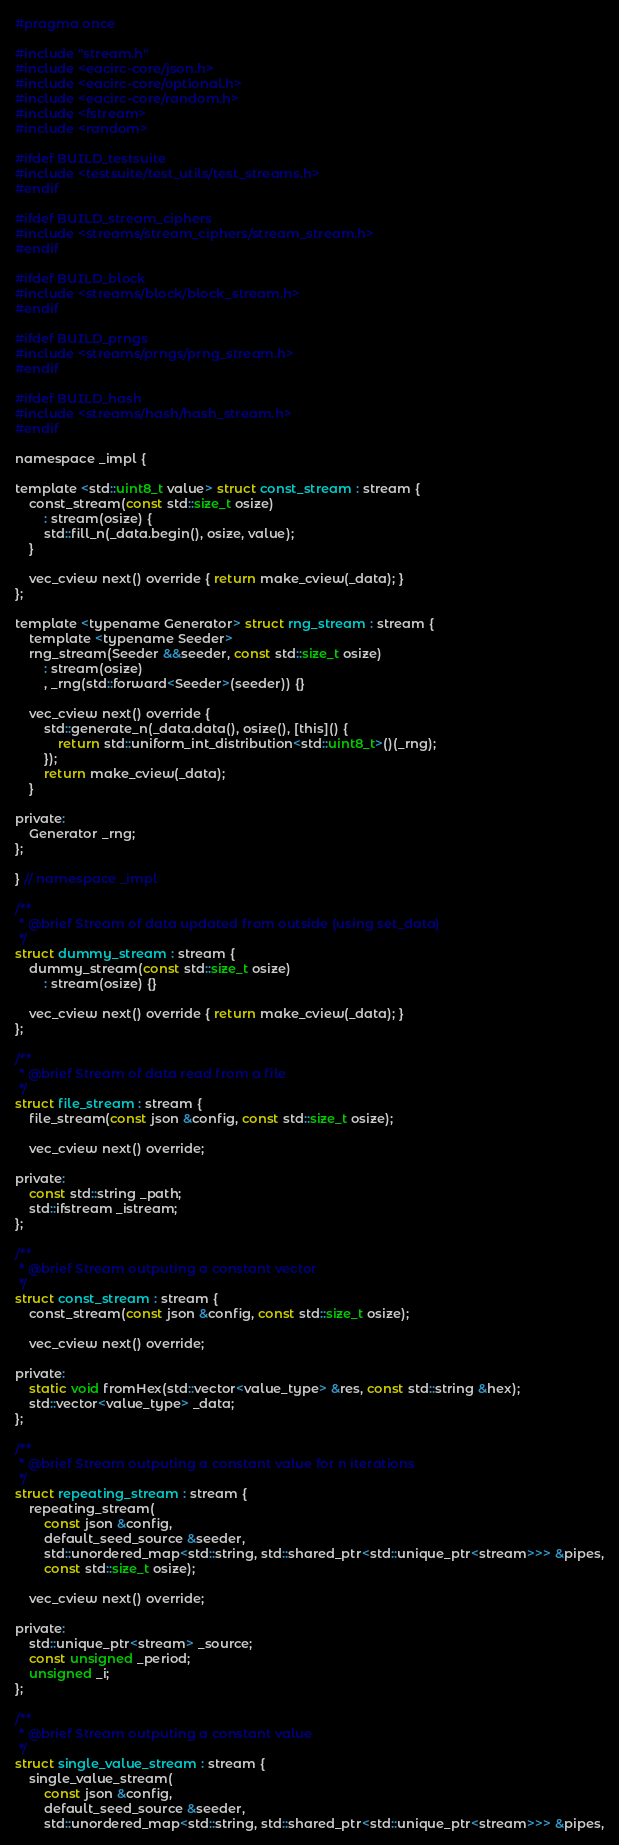Convert code to text. <code><loc_0><loc_0><loc_500><loc_500><_C_>#pragma once

#include "stream.h"
#include <eacirc-core/json.h>
#include <eacirc-core/optional.h>
#include <eacirc-core/random.h>
#include <fstream>
#include <random>

#ifdef BUILD_testsuite
#include <testsuite/test_utils/test_streams.h>
#endif

#ifdef BUILD_stream_ciphers
#include <streams/stream_ciphers/stream_stream.h>
#endif

#ifdef BUILD_block
#include <streams/block/block_stream.h>
#endif

#ifdef BUILD_prngs
#include <streams/prngs/prng_stream.h>
#endif

#ifdef BUILD_hash
#include <streams/hash/hash_stream.h>
#endif

namespace _impl {

template <std::uint8_t value> struct const_stream : stream {
    const_stream(const std::size_t osize)
        : stream(osize) {
        std::fill_n(_data.begin(), osize, value);
    }

    vec_cview next() override { return make_cview(_data); }
};

template <typename Generator> struct rng_stream : stream {
    template <typename Seeder>
    rng_stream(Seeder &&seeder, const std::size_t osize)
        : stream(osize)
        , _rng(std::forward<Seeder>(seeder)) {}

    vec_cview next() override {
        std::generate_n(_data.data(), osize(), [this]() {
            return std::uniform_int_distribution<std::uint8_t>()(_rng);
        });
        return make_cview(_data);
    }

private:
    Generator _rng;
};

} // namespace _impl

/**
 * @brief Stream of data updated from outside (using set_data)
 */
struct dummy_stream : stream {
    dummy_stream(const std::size_t osize)
        : stream(osize) {}

    vec_cview next() override { return make_cview(_data); }
};

/**
 * @brief Stream of data read from a file
 */
struct file_stream : stream {
    file_stream(const json &config, const std::size_t osize);

    vec_cview next() override;

private:
    const std::string _path;
    std::ifstream _istream;
};

/**
 * @brief Stream outputing a constant vector
 */
struct const_stream : stream {
    const_stream(const json &config, const std::size_t osize);

    vec_cview next() override;

private:
    static void fromHex(std::vector<value_type> &res, const std::string &hex);
    std::vector<value_type> _data;
};

/**
 * @brief Stream outputing a constant value for n iterations
 */
struct repeating_stream : stream {
    repeating_stream(
        const json &config,
        default_seed_source &seeder,
        std::unordered_map<std::string, std::shared_ptr<std::unique_ptr<stream>>> &pipes,
        const std::size_t osize);

    vec_cview next() override;

private:
    std::unique_ptr<stream> _source;
    const unsigned _period;
    unsigned _i;
};

/**
 * @brief Stream outputing a constant value
 */
struct single_value_stream : stream {
    single_value_stream(
        const json &config,
        default_seed_source &seeder,
        std::unordered_map<std::string, std::shared_ptr<std::unique_ptr<stream>>> &pipes,</code> 